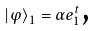Convert formula to latex. <formula><loc_0><loc_0><loc_500><loc_500>\left | \varphi \right \rangle _ { 1 } = \alpha e _ { 1 } ^ { t } \text {,}</formula> 